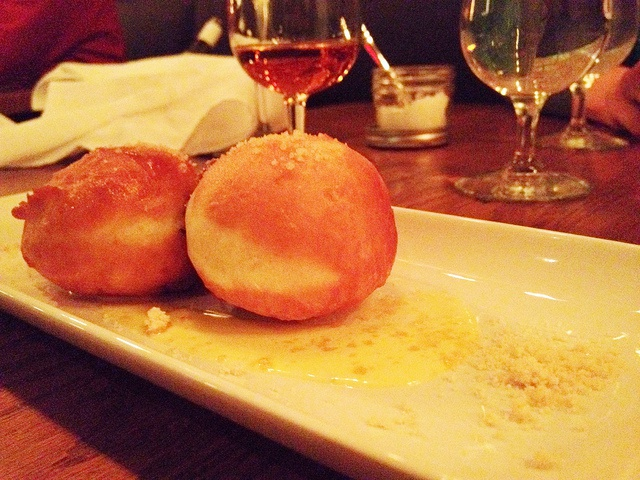Describe the objects in this image and their specific colors. I can see donut in brown, red, orange, and salmon tones, donut in brown, red, and salmon tones, dining table in brown, maroon, and red tones, wine glass in brown, maroon, and black tones, and people in brown, maroon, and black tones in this image. 